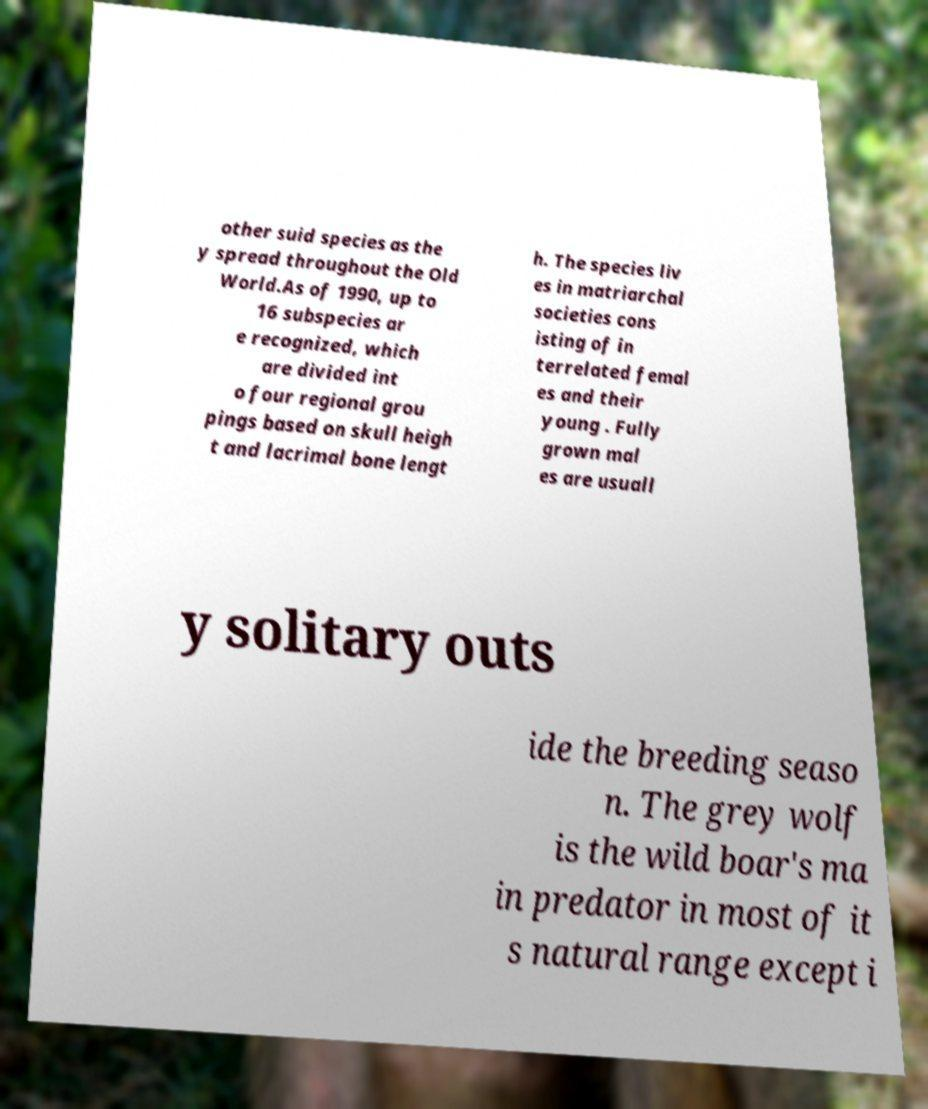There's text embedded in this image that I need extracted. Can you transcribe it verbatim? other suid species as the y spread throughout the Old World.As of 1990, up to 16 subspecies ar e recognized, which are divided int o four regional grou pings based on skull heigh t and lacrimal bone lengt h. The species liv es in matriarchal societies cons isting of in terrelated femal es and their young . Fully grown mal es are usuall y solitary outs ide the breeding seaso n. The grey wolf is the wild boar's ma in predator in most of it s natural range except i 